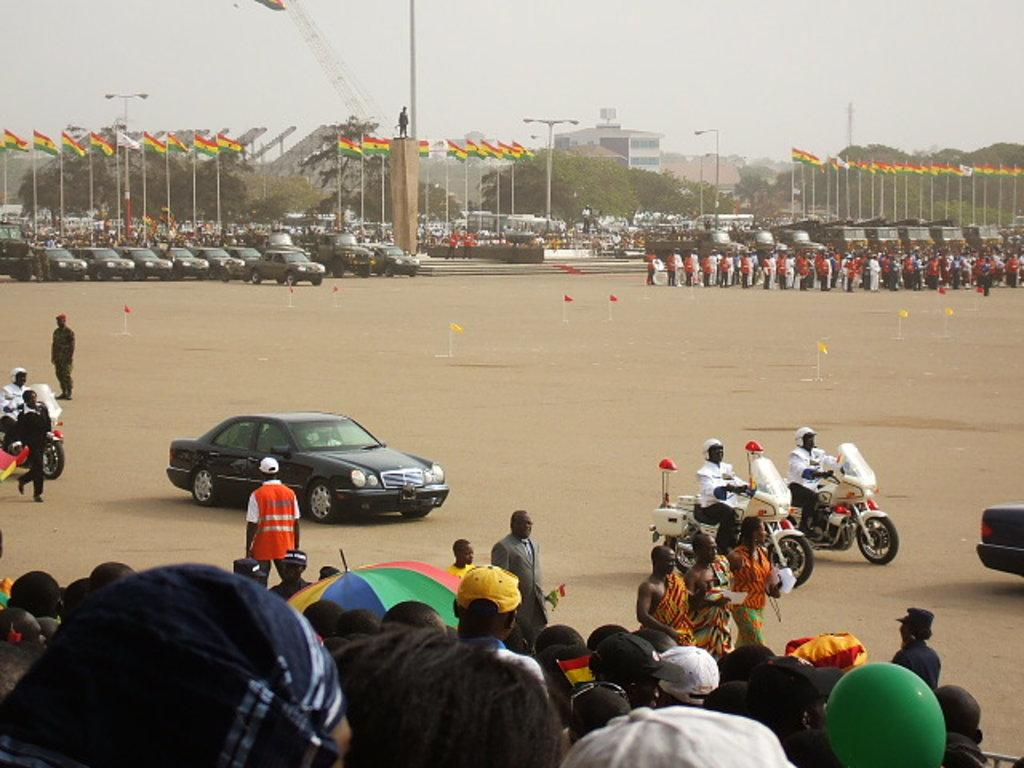What can be seen in the front of the image? In the front of the image, there are people, an umbrella, vehicles, and a flag. Can you describe the background of the image? In the background of the image, there are flags, buildings, light poles, trees, people, the sky, a statue, and vehicles. What type of badge is being worn by the committee members in the image? There is no mention of a committee or badges in the image. Can you see any pipes in the image? There are no pipes visible in the image. 